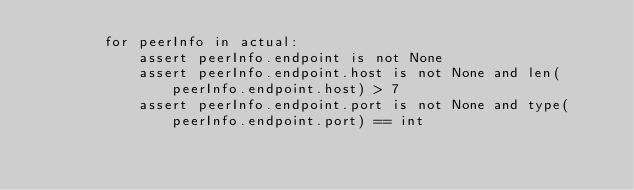<code> <loc_0><loc_0><loc_500><loc_500><_Python_>        for peerInfo in actual:
            assert peerInfo.endpoint is not None
            assert peerInfo.endpoint.host is not None and len(peerInfo.endpoint.host) > 7
            assert peerInfo.endpoint.port is not None and type(peerInfo.endpoint.port) == int
</code> 